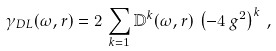Convert formula to latex. <formula><loc_0><loc_0><loc_500><loc_500>\gamma _ { D L } ( \omega , r ) = 2 \, \sum _ { k = 1 } { \mathbb { D } } ^ { k } ( \omega , r ) \, \left ( - 4 \, g ^ { 2 } \right ) ^ { k } \, ,</formula> 